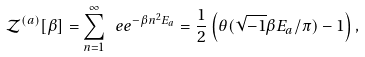Convert formula to latex. <formula><loc_0><loc_0><loc_500><loc_500>\mathcal { Z } ^ { ( a ) } [ \beta ] = \sum _ { n = 1 } ^ { \infty } \ e e ^ { - \beta n ^ { 2 } E _ { a } } = \frac { 1 } { 2 } \left ( \theta ( \sqrt { - 1 } \beta E _ { a } / \pi ) - 1 \right ) ,</formula> 